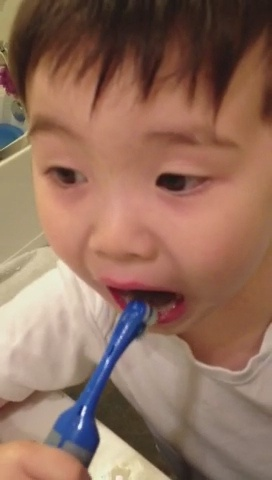Describe the objects in this image and their specific colors. I can see people in gray, olive, salmon, black, and tan tones and toothbrush in olive, blue, navy, and gray tones in this image. 